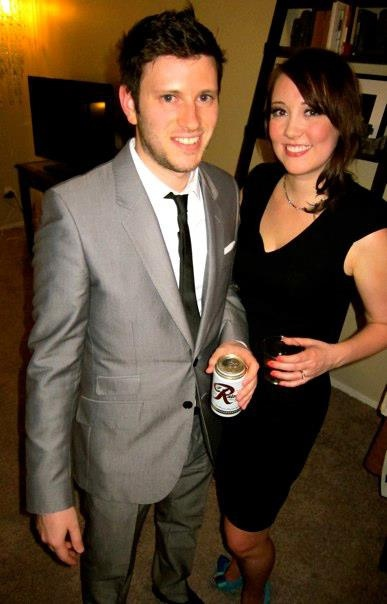Describe the objects in this image and their specific colors. I can see people in khaki, black, darkgray, and gray tones, people in khaki, black, salmon, and maroon tones, tv in khaki, black, maroon, and brown tones, tie in khaki, black, darkgray, white, and gray tones, and book in black and khaki tones in this image. 